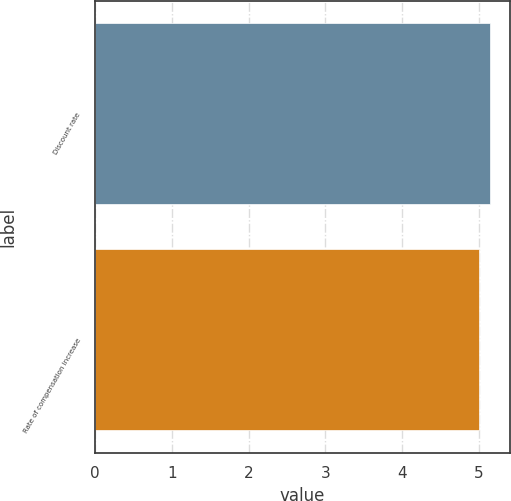Convert chart. <chart><loc_0><loc_0><loc_500><loc_500><bar_chart><fcel>Discount rate<fcel>Rate of compensation increase<nl><fcel>5.15<fcel>5<nl></chart> 